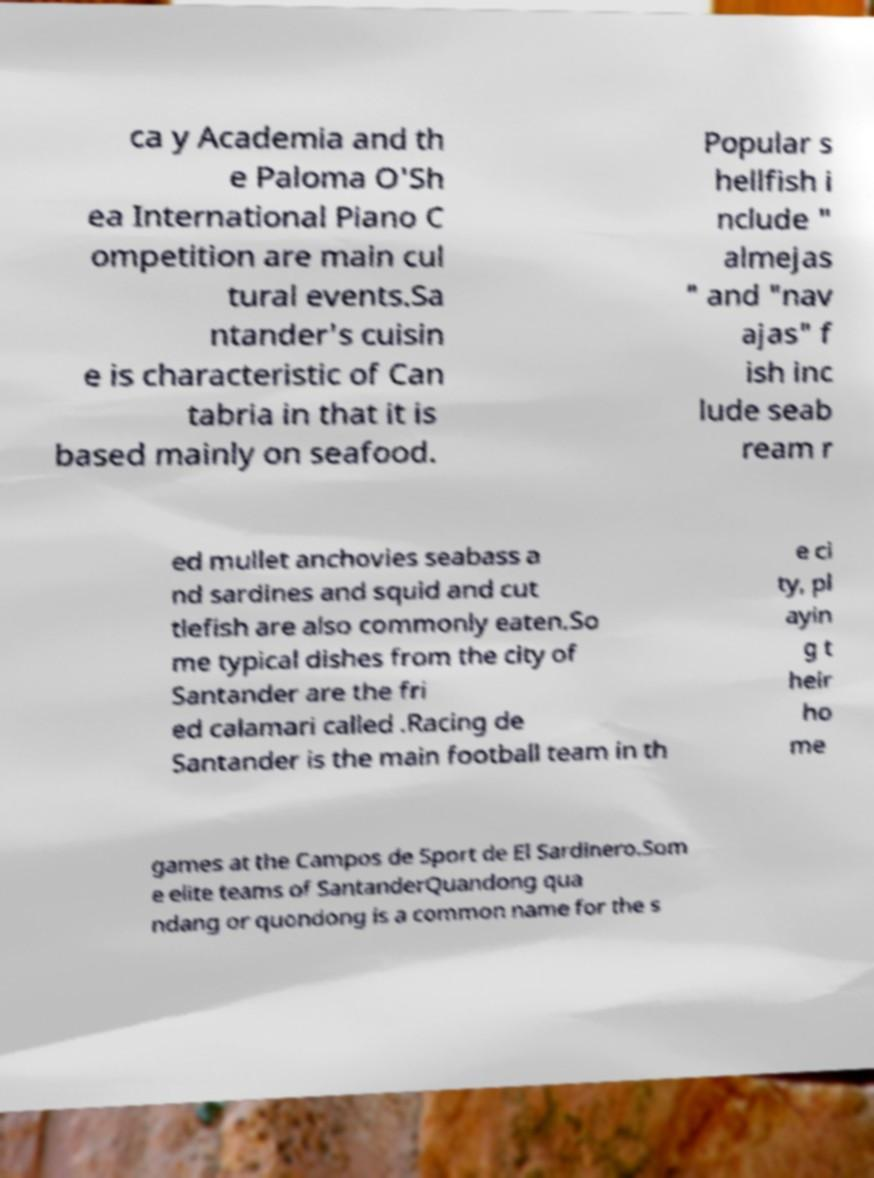Please identify and transcribe the text found in this image. ca y Academia and th e Paloma O'Sh ea International Piano C ompetition are main cul tural events.Sa ntander's cuisin e is characteristic of Can tabria in that it is based mainly on seafood. Popular s hellfish i nclude " almejas " and "nav ajas" f ish inc lude seab ream r ed mullet anchovies seabass a nd sardines and squid and cut tlefish are also commonly eaten.So me typical dishes from the city of Santander are the fri ed calamari called .Racing de Santander is the main football team in th e ci ty, pl ayin g t heir ho me games at the Campos de Sport de El Sardinero.Som e elite teams of SantanderQuandong qua ndang or quondong is a common name for the s 